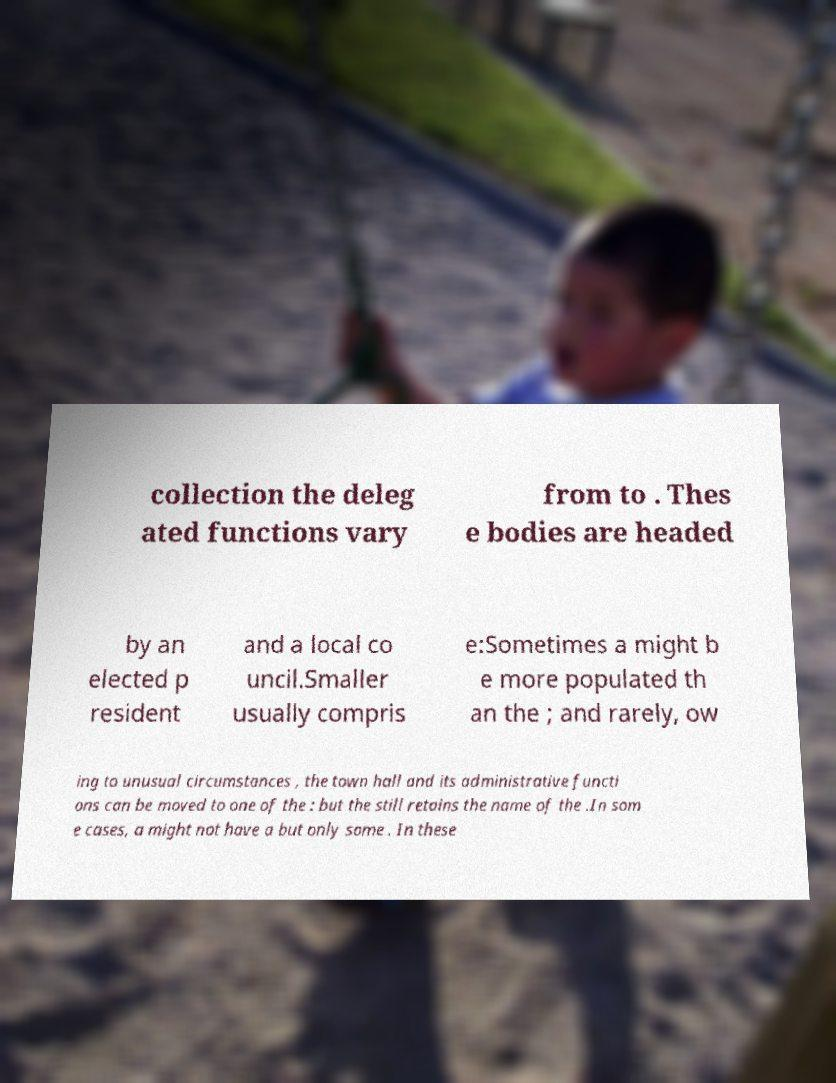I need the written content from this picture converted into text. Can you do that? collection the deleg ated functions vary from to . Thes e bodies are headed by an elected p resident and a local co uncil.Smaller usually compris e:Sometimes a might b e more populated th an the ; and rarely, ow ing to unusual circumstances , the town hall and its administrative functi ons can be moved to one of the : but the still retains the name of the .In som e cases, a might not have a but only some . In these 